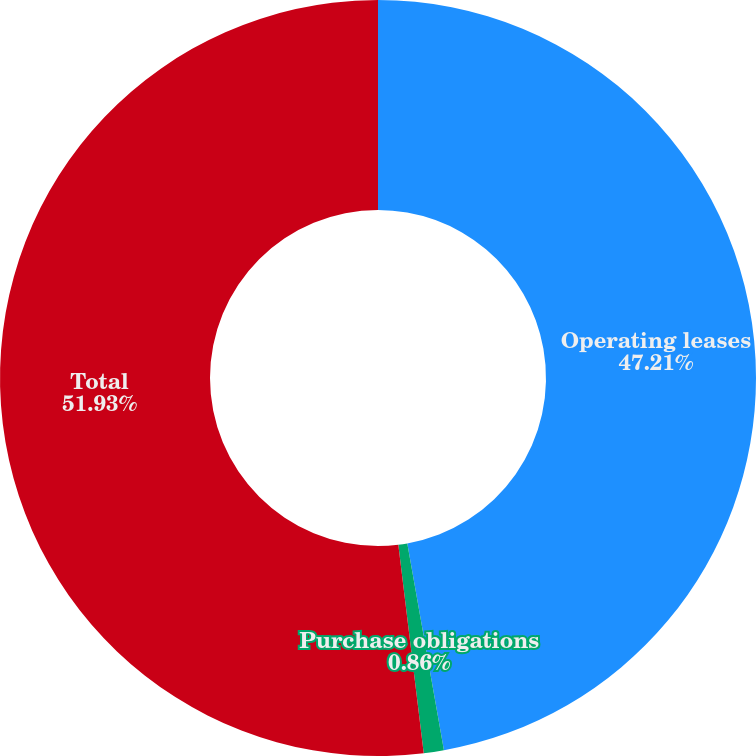<chart> <loc_0><loc_0><loc_500><loc_500><pie_chart><fcel>Operating leases<fcel>Purchase obligations<fcel>Total<nl><fcel>47.21%<fcel>0.86%<fcel>51.93%<nl></chart> 